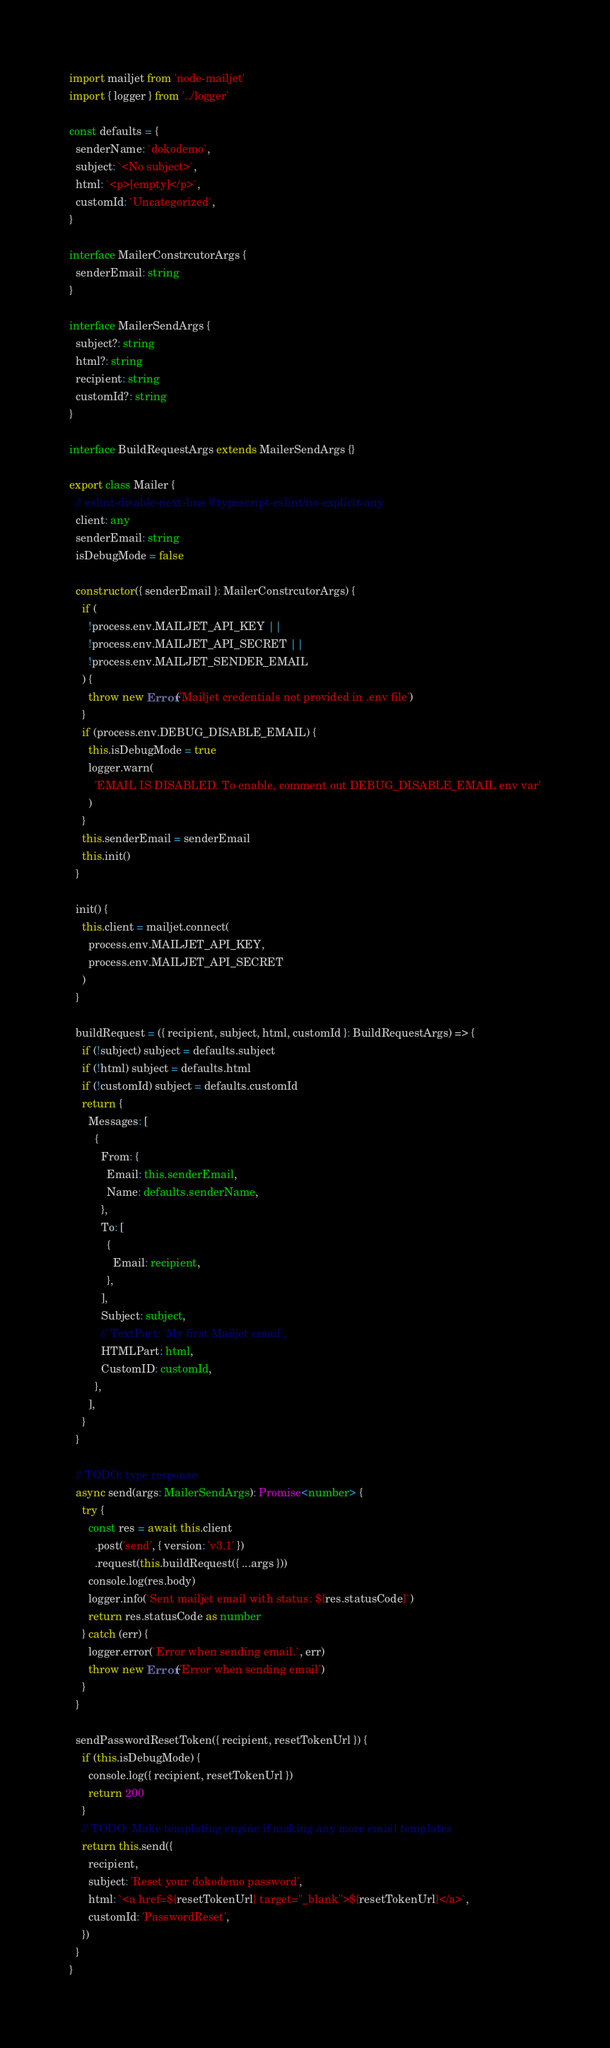<code> <loc_0><loc_0><loc_500><loc_500><_TypeScript_>import mailjet from 'node-mailjet'
import { logger } from '../logger'

const defaults = {
  senderName: `dokodemo`,
  subject: `<No subject>`,
  html: `<p>[empty]</p>`,
  customId: `Uncategorized`,
}

interface MailerConstrcutorArgs {
  senderEmail: string
}

interface MailerSendArgs {
  subject?: string
  html?: string
  recipient: string
  customId?: string
}

interface BuildRequestArgs extends MailerSendArgs {}

export class Mailer {
  // eslint-disable-next-line @typescript-eslint/no-explicit-any
  client: any
  senderEmail: string
  isDebugMode = false

  constructor({ senderEmail }: MailerConstrcutorArgs) {
    if (
      !process.env.MAILJET_API_KEY ||
      !process.env.MAILJET_API_SECRET ||
      !process.env.MAILJET_SENDER_EMAIL
    ) {
      throw new Error('Mailjet credentials not provided in .env file')
    }
    if (process.env.DEBUG_DISABLE_EMAIL) {
      this.isDebugMode = true
      logger.warn(
        'EMAIL IS DISABLED. To enable, comment out DEBUG_DISABLE_EMAIL env var'
      )
    }
    this.senderEmail = senderEmail
    this.init()
  }

  init() {
    this.client = mailjet.connect(
      process.env.MAILJET_API_KEY,
      process.env.MAILJET_API_SECRET
    )
  }

  buildRequest = ({ recipient, subject, html, customId }: BuildRequestArgs) => {
    if (!subject) subject = defaults.subject
    if (!html) subject = defaults.html
    if (!customId) subject = defaults.customId
    return {
      Messages: [
        {
          From: {
            Email: this.senderEmail,
            Name: defaults.senderName,
          },
          To: [
            {
              Email: recipient,
            },
          ],
          Subject: subject,
          // TextPart: 'My first Mailjet email',
          HTMLPart: html,
          CustomID: customId,
        },
      ],
    }
  }

  // TODO: type response
  async send(args: MailerSendArgs): Promise<number> {
    try {
      const res = await this.client
        .post('send', { version: 'v3.1' })
        .request(this.buildRequest({ ...args }))
      console.log(res.body)
      logger.info(`Sent mailjet email with status: ${res.statusCode}`)
      return res.statusCode as number
    } catch (err) {
      logger.error(`Error when sending email.`, err)
      throw new Error('Error when sending email')
    }
  }

  sendPasswordResetToken({ recipient, resetTokenUrl }) {
    if (this.isDebugMode) {
      console.log({ recipient, resetTokenUrl })
      return 200
    }
    // TODO: Make templating engine if making any more email templates
    return this.send({
      recipient,
      subject: 'Reset your dokodemo password',
      html: `<a href=${resetTokenUrl} target="_blank">${resetTokenUrl}</a>`,
      customId: 'PasswordReset',
    })
  }
}
</code> 